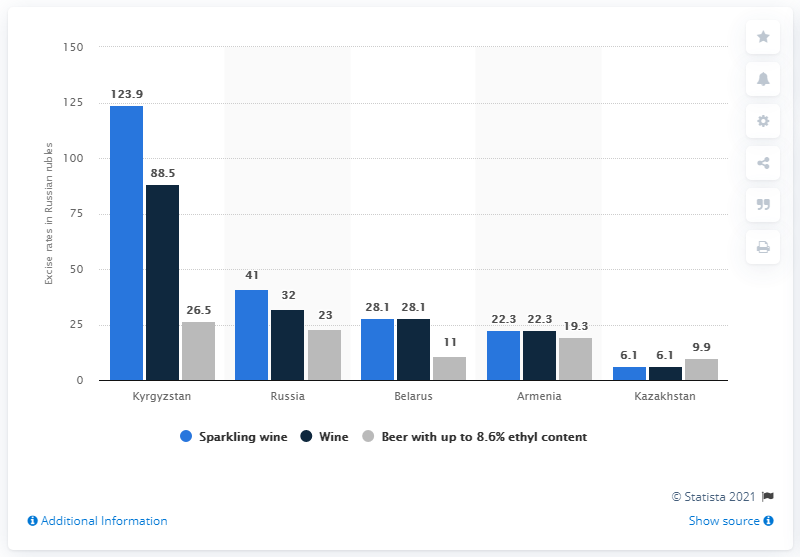Give some essential details in this illustration. Kyrgyzstan had the highest excise rates per liter of alcoholic beverages among all countries, according to the latest data. The country with the lowest alcohol taxes within the union was Kazakhstan. 